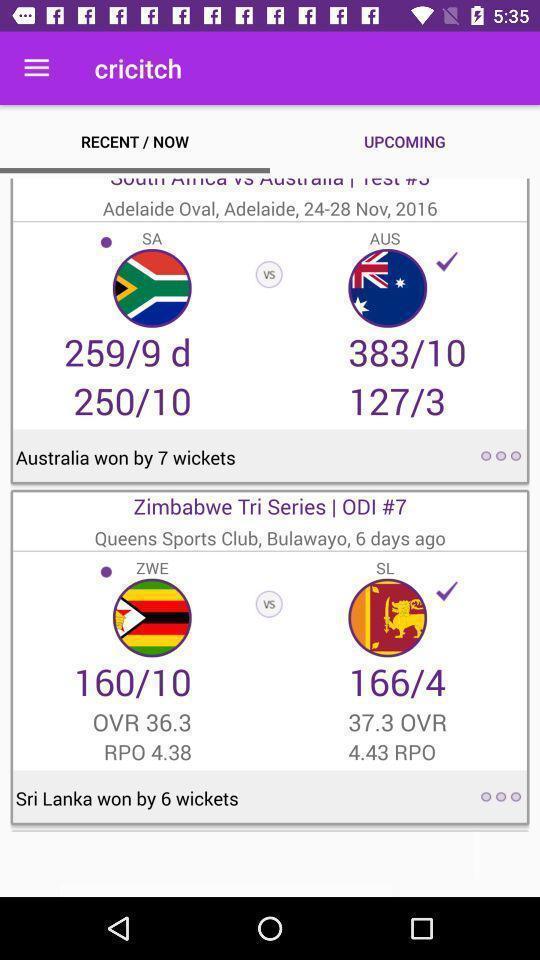What details can you identify in this image? Page showing the scorecard of cricket matches. 